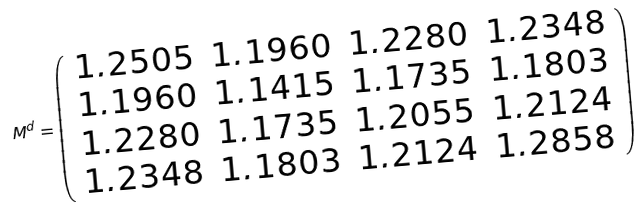Convert formula to latex. <formula><loc_0><loc_0><loc_500><loc_500>M ^ { d } = \left ( \begin{array} { c c c c } 1 . 2 5 0 5 & 1 . 1 9 6 0 & 1 . 2 2 8 0 & 1 . 2 3 4 8 \\ 1 . 1 9 6 0 & 1 . 1 4 1 5 & 1 . 1 7 3 5 & 1 . 1 8 0 3 \\ 1 . 2 2 8 0 & 1 . 1 7 3 5 & 1 . 2 0 5 5 & 1 . 2 1 2 4 \\ 1 . 2 3 4 8 & 1 . 1 8 0 3 & 1 . 2 1 2 4 & 1 . 2 8 5 8 \\ \end{array} \right )</formula> 